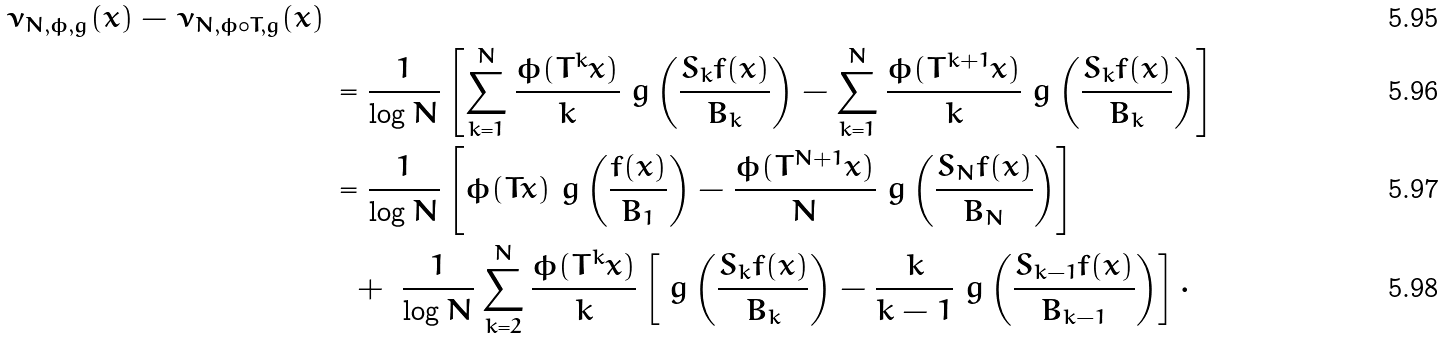<formula> <loc_0><loc_0><loc_500><loc_500>\nu _ { N , \phi , g } ( x ) - \nu _ { N , \phi \circ T , g } ( x ) \, & \\ & = \frac { 1 } { \log N } \left [ \sum _ { k = 1 } ^ { N } \frac { \phi ( T ^ { k } x ) } { k } \ g \left ( \frac { S _ { k } f ( x ) } { B _ { k } } \right ) - \sum _ { k = 1 } ^ { N } \frac { \phi ( T ^ { k + 1 } x ) } { k } \ g \left ( \frac { S _ { k } f ( x ) } { B _ { k } } \right ) \right ] \\ & = \frac { 1 } { \log N } \left [ \phi ( T x ) \ g \left ( \frac { f ( x ) } { B _ { 1 } } \right ) - \frac { \phi ( T ^ { N + 1 } x ) } { N } \ g \left ( \frac { S _ { N } f ( x ) } { B _ { N } } \right ) \right ] \\ & \ \ + \ \frac { 1 } { \log N } \sum _ { k = 2 } ^ { N } \frac { \phi ( T ^ { k } x ) } { k } \left [ \ g \left ( \frac { S _ { k } f ( x ) } { B _ { k } } \right ) - \frac { k } { k - 1 } \ g \left ( \frac { S _ { k - 1 } f ( x ) } { B _ { k - 1 } } \right ) \right ] \cdot</formula> 